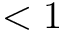<formula> <loc_0><loc_0><loc_500><loc_500>< 1</formula> 